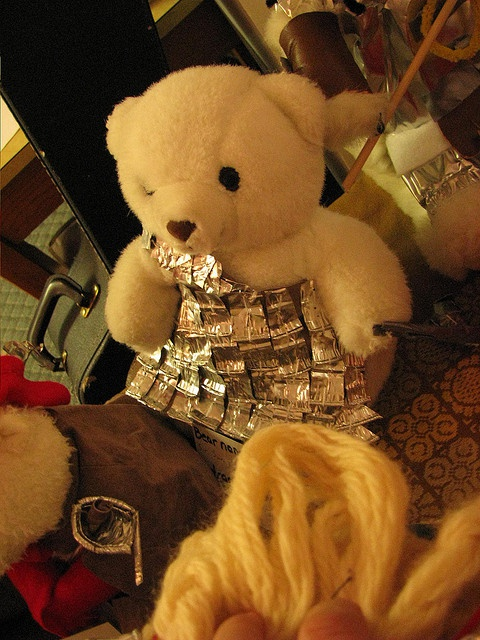Describe the objects in this image and their specific colors. I can see teddy bear in black, olive, tan, and maroon tones and suitcase in black and olive tones in this image. 